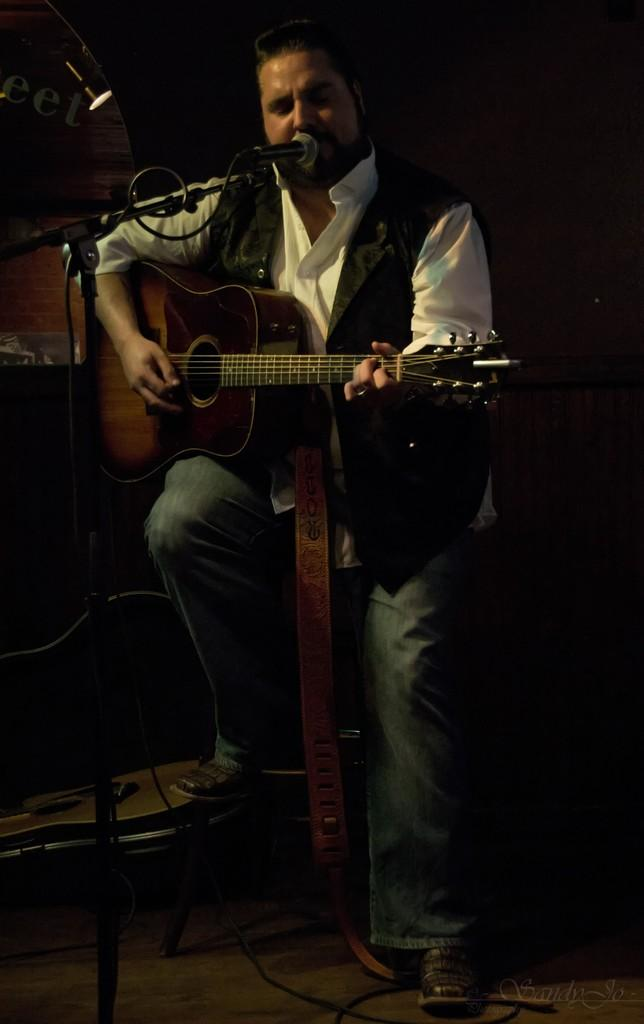What is the man in the image holding? The man is holding a guitar. Where is the man sitting in the image? The man is sitting in front of a mic. What can be seen in the image that provides illumination? There is a light visible in the image. What type of carriage is the man using to transport the guitar in the image? There is no carriage present in the image; the man is simply holding the guitar. What religion is the man practicing in the image? There is no indication of the man's religion in the image. 